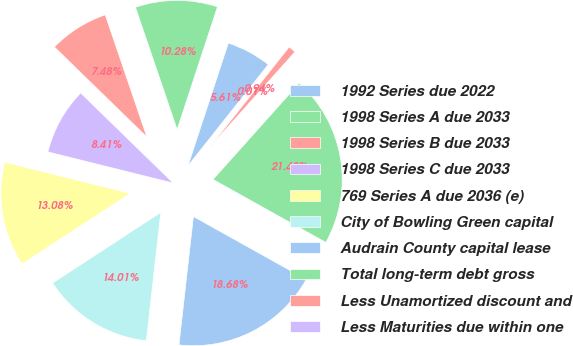Convert chart to OTSL. <chart><loc_0><loc_0><loc_500><loc_500><pie_chart><fcel>1992 Series due 2022<fcel>1998 Series A due 2033<fcel>1998 Series B due 2033<fcel>1998 Series C due 2033<fcel>769 Series A due 2036 (e)<fcel>City of Bowling Green capital<fcel>Audrain County capital lease<fcel>Total long-term debt gross<fcel>Less Unamortized discount and<fcel>Less Maturities due within one<nl><fcel>5.61%<fcel>10.28%<fcel>7.48%<fcel>8.41%<fcel>13.08%<fcel>14.01%<fcel>18.68%<fcel>21.48%<fcel>0.94%<fcel>0.01%<nl></chart> 